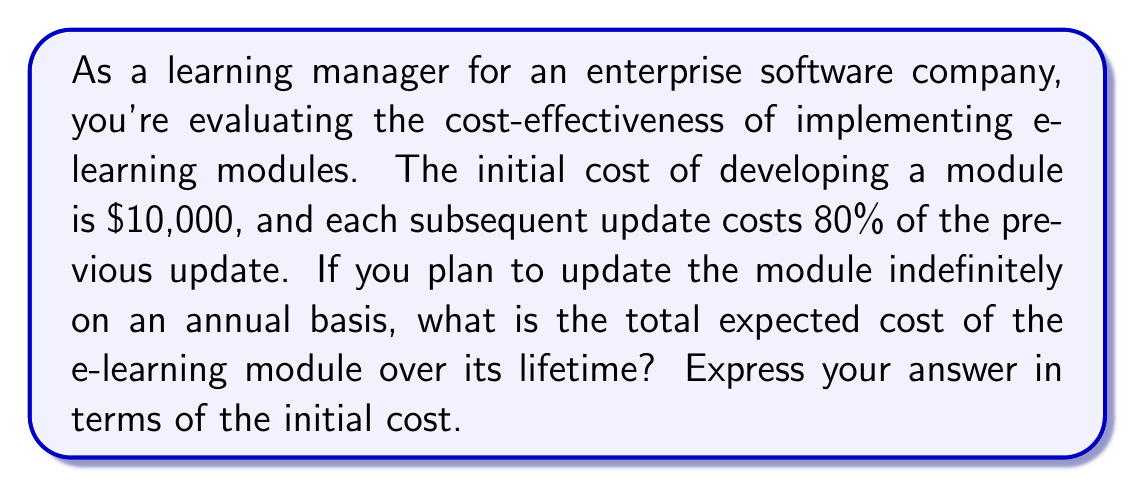Teach me how to tackle this problem. Let's approach this step-by-step using an infinite geometric series:

1) The initial cost is $10,000. Let's call this $a$.

2) Each subsequent update costs 80% of the previous one. This means our common ratio $r$ is 0.8.

3) The costs form the following series:
   $a + ar + ar^2 + ar^3 + ...$

4) This is an infinite geometric series with $|r| < 1$ (since 0.8 < 1).

5) The sum of an infinite geometric series is given by the formula:
   $S_{\infty} = \frac{a}{1-r}$, where $|r| < 1$

6) Substituting our values:
   $S_{\infty} = \frac{a}{1-0.8} = \frac{a}{0.2} = 5a$

7) Since $a$ represents our initial cost of $10,000, the total cost is 5 times the initial cost.

Therefore, the total expected cost over the lifetime of the e-learning module is 5 times the initial cost.
Answer: $5a$ or 5 times the initial cost 